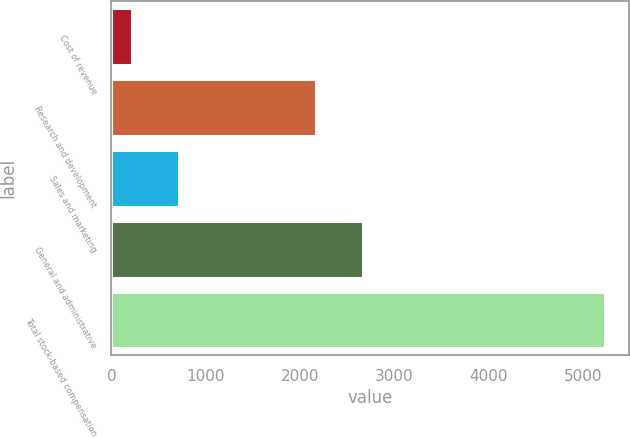Convert chart. <chart><loc_0><loc_0><loc_500><loc_500><bar_chart><fcel>Cost of revenue<fcel>Research and development<fcel>Sales and marketing<fcel>General and administrative<fcel>Total stock-based compensation<nl><fcel>220<fcel>2165<fcel>720.7<fcel>2665.7<fcel>5227<nl></chart> 